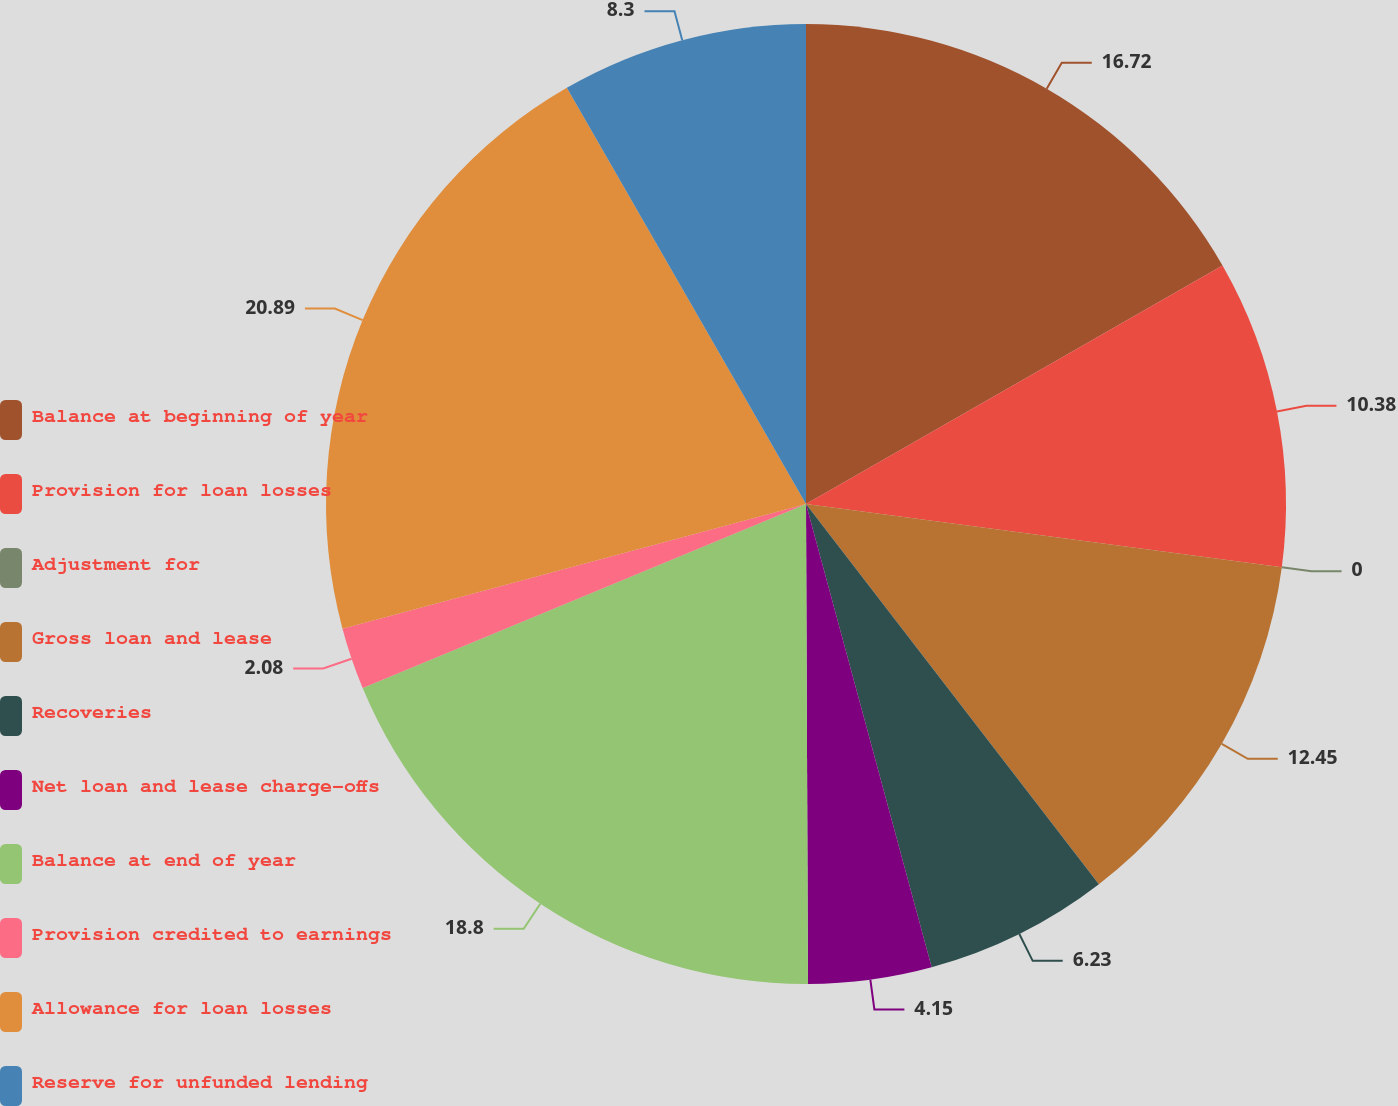<chart> <loc_0><loc_0><loc_500><loc_500><pie_chart><fcel>Balance at beginning of year<fcel>Provision for loan losses<fcel>Adjustment for<fcel>Gross loan and lease<fcel>Recoveries<fcel>Net loan and lease charge-offs<fcel>Balance at end of year<fcel>Provision credited to earnings<fcel>Allowance for loan losses<fcel>Reserve for unfunded lending<nl><fcel>16.72%<fcel>10.38%<fcel>0.0%<fcel>12.45%<fcel>6.23%<fcel>4.15%<fcel>18.8%<fcel>2.08%<fcel>20.88%<fcel>8.3%<nl></chart> 